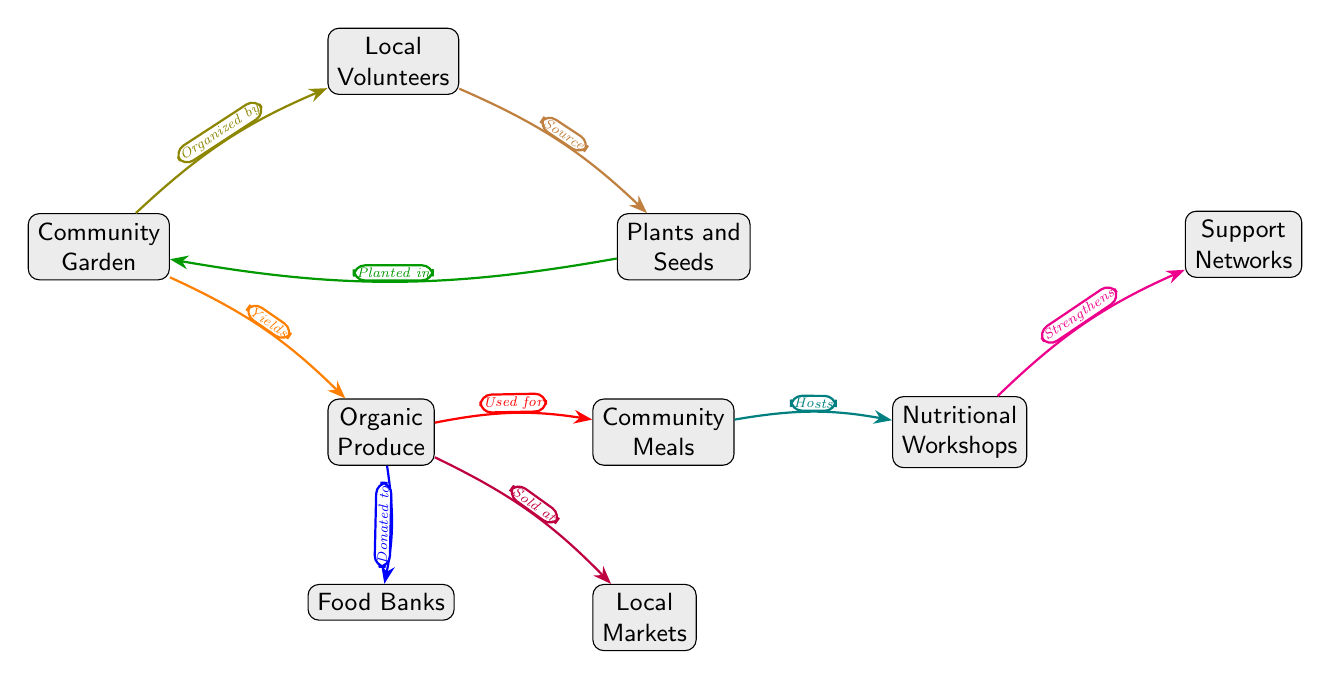What is the primary component of the diagram? The main element at the center of the diagram is the "Community Garden," which is the starting point for all processes and connections illustrated.
Answer: Community Garden How many arrows are depicted in the diagram? By counting each arrow that shows a connection between nodes in the diagram, there are a total of eight arrows present.
Answer: 8 Which node receives donations from the "Organic Produce"? The "Food Banks" node is connected by an arrow that indicates it receives organic produce, showing the flow of support to those in need.
Answer: Food Banks What do "Local Volunteers" provide to the diagram? The "Local Volunteers" are linked to the "Plants and Seeds" node, meaning they provide the essential resources for planting within the community garden.
Answer: Source What type of events are hosted by "Community Meals"? The "Community Meals" node is connected to the "Nutritional Workshops" node, indicating that these workshops are events that utilize the prepared meals and promote nutrition within the community.
Answer: Hosts What do "Organic Produce" and "Local Markets" have in common? Both nodes are connected, and "Organic Produce" is sold at "Local Markets," highlighting the relationship between the produce created in the gardens and its point of sale within the community.
Answer: Sold at Which nodes are involved in the usage of "Organic Produce"? The "Organic Produce" is utilized in two separate pathways indicated by arrows: it is used for "Community Meals" as well as donated to "Food Banks," showing the dual purpose of the produce generated from the garden.
Answer: Community Meals, Food Banks How does "Support Networks" relate to "Nutritional Workshops"? The "Support Networks" node is receiving benefits from the "Nutritional Workshops," demonstrating that these workshops play a role in strengthening community ties through shared knowledge about nutrition.
Answer: Strengthens What is the function of "Plants and Seeds" in the community garden? The "Plants and Seeds" play a crucial role as they are the resources that are planted in the "Community Garden," initiating the growing process and contributing to local food security.
Answer: Planted in 